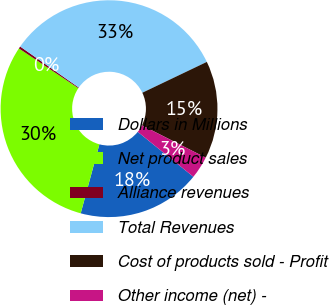Convert chart. <chart><loc_0><loc_0><loc_500><loc_500><pie_chart><fcel>Dollars in Millions<fcel>Net product sales<fcel>Alliance revenues<fcel>Total Revenues<fcel>Cost of products sold - Profit<fcel>Other income (net) -<nl><fcel>18.4%<fcel>30.17%<fcel>0.34%<fcel>33.19%<fcel>14.56%<fcel>3.35%<nl></chart> 